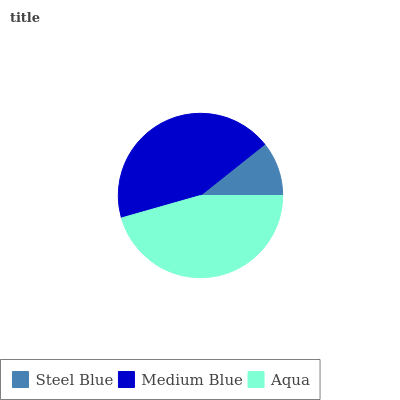Is Steel Blue the minimum?
Answer yes or no. Yes. Is Aqua the maximum?
Answer yes or no. Yes. Is Medium Blue the minimum?
Answer yes or no. No. Is Medium Blue the maximum?
Answer yes or no. No. Is Medium Blue greater than Steel Blue?
Answer yes or no. Yes. Is Steel Blue less than Medium Blue?
Answer yes or no. Yes. Is Steel Blue greater than Medium Blue?
Answer yes or no. No. Is Medium Blue less than Steel Blue?
Answer yes or no. No. Is Medium Blue the high median?
Answer yes or no. Yes. Is Medium Blue the low median?
Answer yes or no. Yes. Is Steel Blue the high median?
Answer yes or no. No. Is Steel Blue the low median?
Answer yes or no. No. 